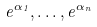<formula> <loc_0><loc_0><loc_500><loc_500>e ^ { \alpha _ { 1 } } , \dots , e ^ { \alpha _ { n } }</formula> 